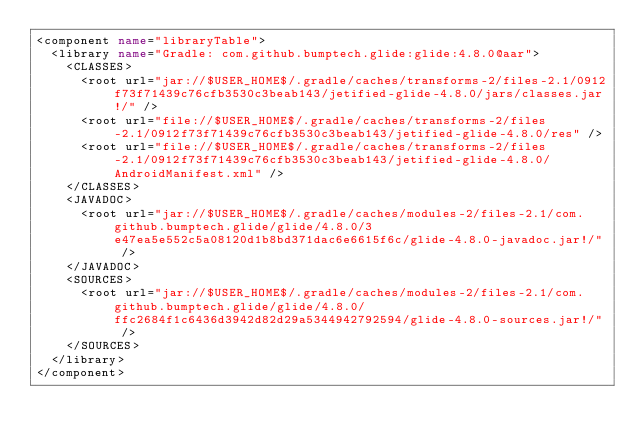Convert code to text. <code><loc_0><loc_0><loc_500><loc_500><_XML_><component name="libraryTable">
  <library name="Gradle: com.github.bumptech.glide:glide:4.8.0@aar">
    <CLASSES>
      <root url="jar://$USER_HOME$/.gradle/caches/transforms-2/files-2.1/0912f73f71439c76cfb3530c3beab143/jetified-glide-4.8.0/jars/classes.jar!/" />
      <root url="file://$USER_HOME$/.gradle/caches/transforms-2/files-2.1/0912f73f71439c76cfb3530c3beab143/jetified-glide-4.8.0/res" />
      <root url="file://$USER_HOME$/.gradle/caches/transforms-2/files-2.1/0912f73f71439c76cfb3530c3beab143/jetified-glide-4.8.0/AndroidManifest.xml" />
    </CLASSES>
    <JAVADOC>
      <root url="jar://$USER_HOME$/.gradle/caches/modules-2/files-2.1/com.github.bumptech.glide/glide/4.8.0/3e47ea5e552c5a08120d1b8bd371dac6e6615f6c/glide-4.8.0-javadoc.jar!/" />
    </JAVADOC>
    <SOURCES>
      <root url="jar://$USER_HOME$/.gradle/caches/modules-2/files-2.1/com.github.bumptech.glide/glide/4.8.0/ffc2684f1c6436d3942d82d29a5344942792594/glide-4.8.0-sources.jar!/" />
    </SOURCES>
  </library>
</component></code> 